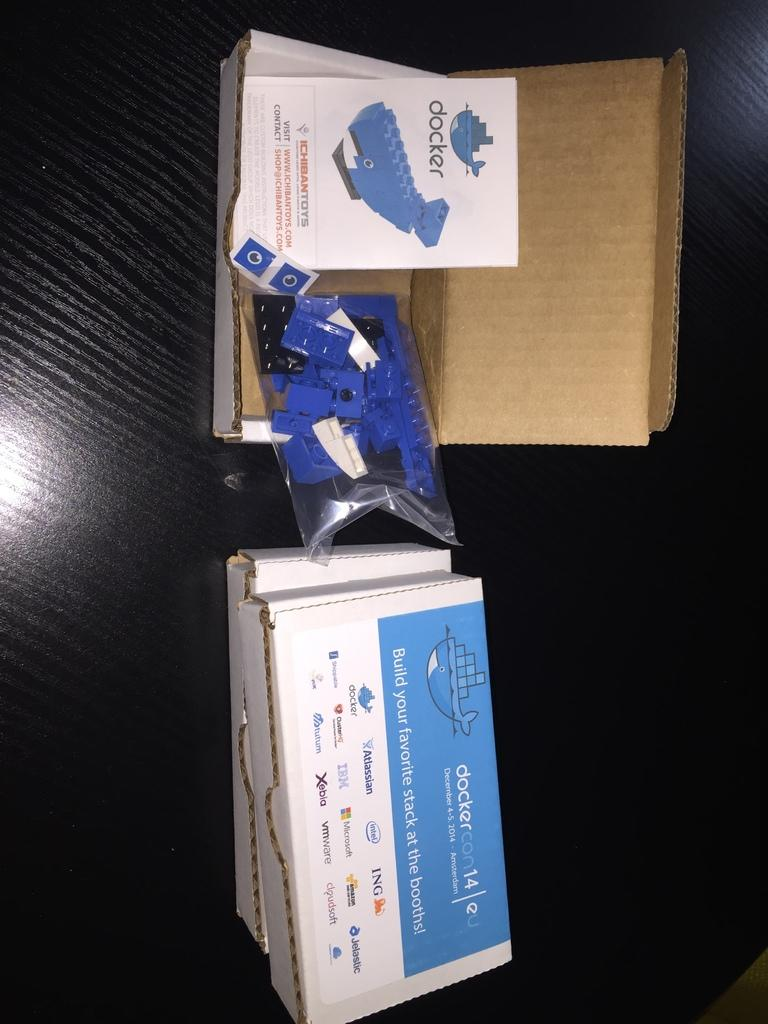<image>
Create a compact narrative representing the image presented. A box with a Lego whale and a booklet that says Docker inside. 